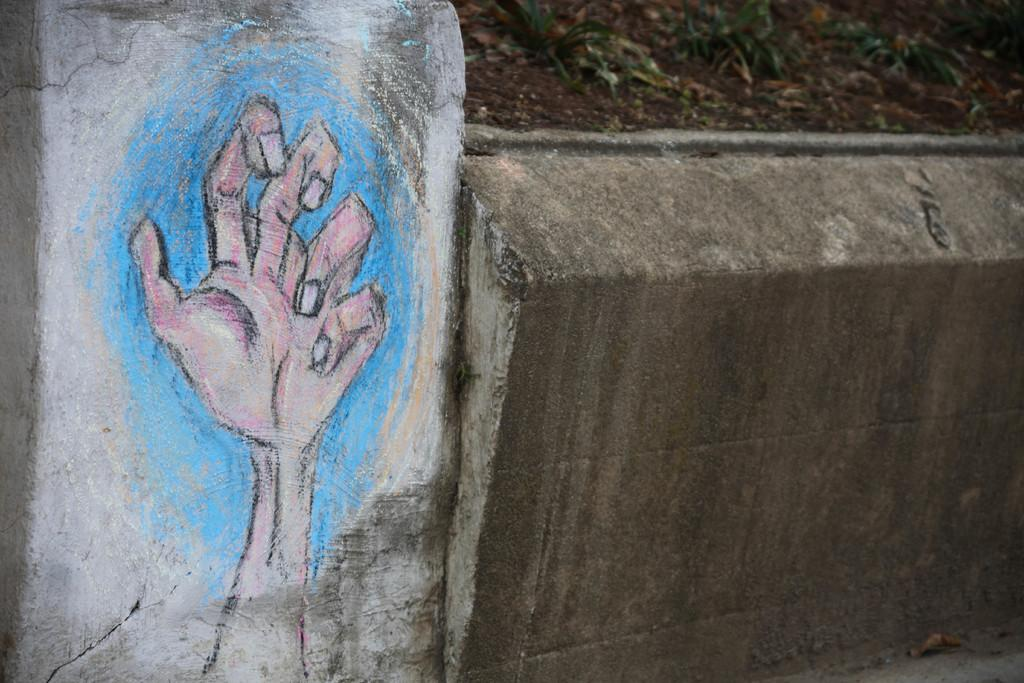What is present on the wall in the image? There is a painting of a hand on the wall. How many pies are displayed on the wall in the image? There are no pies present on the wall in the image; it features a painting of a hand. What type of ticket is visible on the wall in the image? There is no ticket visible on the wall in the image; it features a painting of a hand. 